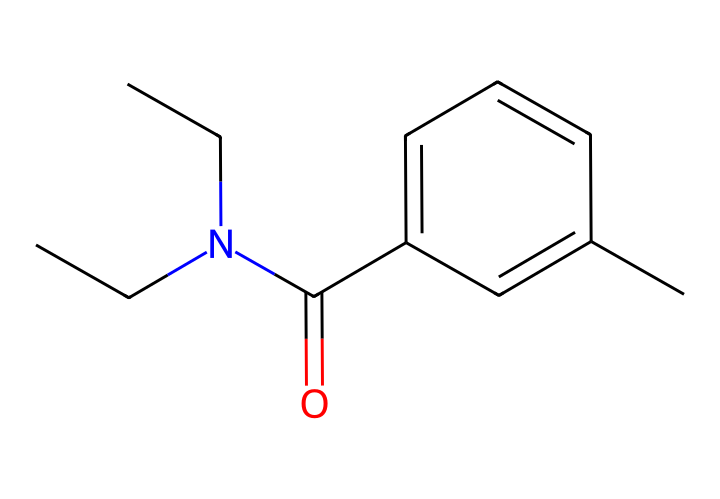What is the name of this chemical? The structure represents N,N-diethyl-meta-toluamide, commonly known as DEET. This is determined by identifying the functional groups and the name associated with the SMILES representation.
Answer: DEET How many carbon atoms are in the structure? By examining the SMILES representation, we count the carbon (C) atoms in the chemical structure. There are 11 carbon atoms explicitly mentioned in the SMILES as part of the main chain and the aromatic ring.
Answer: 11 What functional group is present in this chemical? The structure includes an amide functional group indicated by the presence of a carbonyl (C=O) attached to a nitrogen (N), which defines the presence of the amide.
Answer: amide What is the significance of the nitrogen atom in this chemical? The nitrogen atom contributes to the molecule’s ability to interact with insect olfactory receptors. Nitrogen is part of the amine function, which can modify the electronic properties, enhancing the repellent efficacy.
Answer: repellent How does the aromatic ring influence the properties of DEET? The aromatic ring in the structure provides stability and contributes to the lipophilicity of the molecule, which aids in its ability to penetrate the skin and interact with insects.
Answer: stability What is the total number of bonds present in the structure? Counting both single and double bonds in the SMILES helps in determining the total number of bonds. There are 13 bonds (including various types) present in the structure.
Answer: 13 